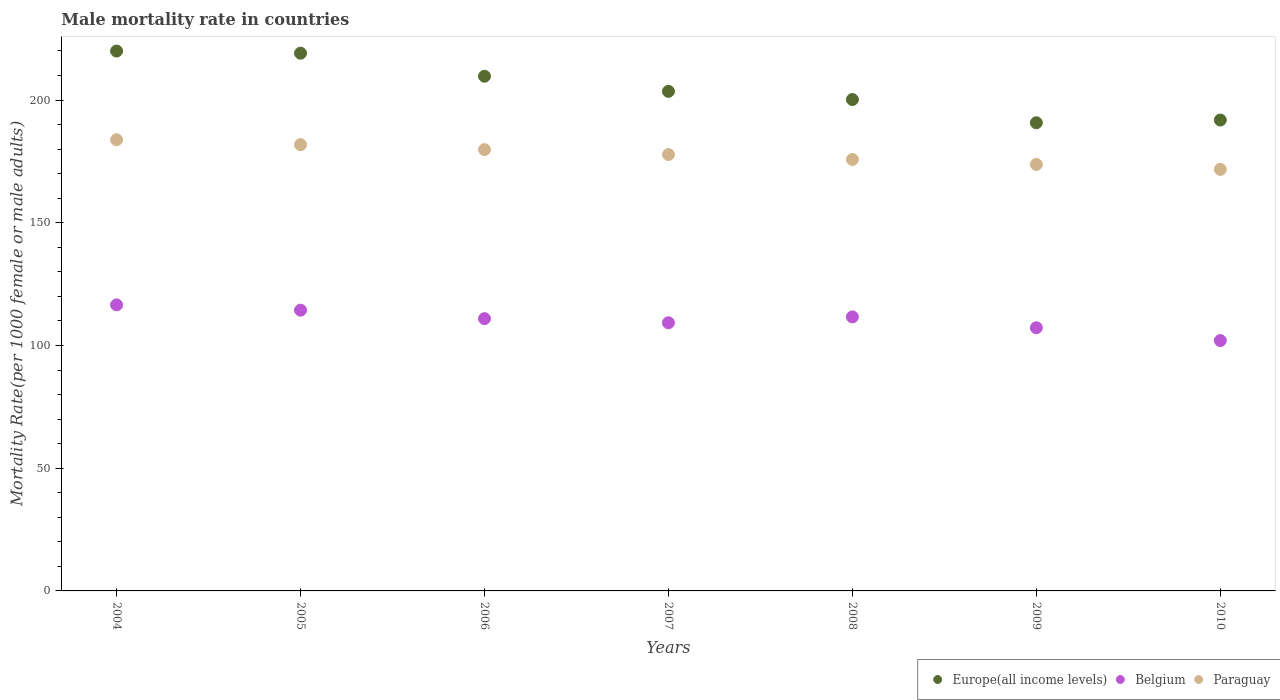Is the number of dotlines equal to the number of legend labels?
Offer a terse response. Yes. What is the male mortality rate in Europe(all income levels) in 2006?
Offer a terse response. 209.7. Across all years, what is the maximum male mortality rate in Paraguay?
Your answer should be very brief. 183.84. Across all years, what is the minimum male mortality rate in Europe(all income levels)?
Offer a very short reply. 190.75. In which year was the male mortality rate in Paraguay maximum?
Keep it short and to the point. 2004. In which year was the male mortality rate in Europe(all income levels) minimum?
Give a very brief answer. 2009. What is the total male mortality rate in Belgium in the graph?
Your response must be concise. 772.02. What is the difference between the male mortality rate in Paraguay in 2007 and that in 2010?
Keep it short and to the point. 6.04. What is the difference between the male mortality rate in Europe(all income levels) in 2006 and the male mortality rate in Paraguay in 2010?
Your answer should be very brief. 37.94. What is the average male mortality rate in Europe(all income levels) per year?
Provide a short and direct response. 205.02. In the year 2004, what is the difference between the male mortality rate in Europe(all income levels) and male mortality rate in Belgium?
Ensure brevity in your answer.  103.41. What is the ratio of the male mortality rate in Paraguay in 2007 to that in 2008?
Make the answer very short. 1.01. Is the difference between the male mortality rate in Europe(all income levels) in 2004 and 2009 greater than the difference between the male mortality rate in Belgium in 2004 and 2009?
Provide a short and direct response. Yes. What is the difference between the highest and the second highest male mortality rate in Europe(all income levels)?
Give a very brief answer. 0.87. What is the difference between the highest and the lowest male mortality rate in Europe(all income levels)?
Your answer should be compact. 29.22. In how many years, is the male mortality rate in Paraguay greater than the average male mortality rate in Paraguay taken over all years?
Offer a terse response. 3. Is the sum of the male mortality rate in Paraguay in 2008 and 2009 greater than the maximum male mortality rate in Europe(all income levels) across all years?
Give a very brief answer. Yes. Is it the case that in every year, the sum of the male mortality rate in Belgium and male mortality rate in Paraguay  is greater than the male mortality rate in Europe(all income levels)?
Your response must be concise. Yes. Is the male mortality rate in Belgium strictly greater than the male mortality rate in Paraguay over the years?
Offer a very short reply. No. How many years are there in the graph?
Your response must be concise. 7. Are the values on the major ticks of Y-axis written in scientific E-notation?
Offer a terse response. No. Does the graph contain any zero values?
Offer a very short reply. No. Does the graph contain grids?
Make the answer very short. No. Where does the legend appear in the graph?
Keep it short and to the point. Bottom right. What is the title of the graph?
Keep it short and to the point. Male mortality rate in countries. What is the label or title of the X-axis?
Your response must be concise. Years. What is the label or title of the Y-axis?
Provide a short and direct response. Mortality Rate(per 1000 female or male adults). What is the Mortality Rate(per 1000 female or male adults) in Europe(all income levels) in 2004?
Your answer should be compact. 219.96. What is the Mortality Rate(per 1000 female or male adults) in Belgium in 2004?
Offer a very short reply. 116.55. What is the Mortality Rate(per 1000 female or male adults) of Paraguay in 2004?
Offer a very short reply. 183.84. What is the Mortality Rate(per 1000 female or male adults) of Europe(all income levels) in 2005?
Give a very brief answer. 219.09. What is the Mortality Rate(per 1000 female or male adults) of Belgium in 2005?
Offer a terse response. 114.39. What is the Mortality Rate(per 1000 female or male adults) in Paraguay in 2005?
Keep it short and to the point. 181.82. What is the Mortality Rate(per 1000 female or male adults) in Europe(all income levels) in 2006?
Offer a terse response. 209.7. What is the Mortality Rate(per 1000 female or male adults) of Belgium in 2006?
Provide a succinct answer. 110.94. What is the Mortality Rate(per 1000 female or male adults) in Paraguay in 2006?
Provide a short and direct response. 179.81. What is the Mortality Rate(per 1000 female or male adults) in Europe(all income levels) in 2007?
Your response must be concise. 203.55. What is the Mortality Rate(per 1000 female or male adults) of Belgium in 2007?
Ensure brevity in your answer.  109.26. What is the Mortality Rate(per 1000 female or male adults) in Paraguay in 2007?
Your answer should be very brief. 177.8. What is the Mortality Rate(per 1000 female or male adults) in Europe(all income levels) in 2008?
Provide a short and direct response. 200.21. What is the Mortality Rate(per 1000 female or male adults) of Belgium in 2008?
Give a very brief answer. 111.64. What is the Mortality Rate(per 1000 female or male adults) of Paraguay in 2008?
Give a very brief answer. 175.78. What is the Mortality Rate(per 1000 female or male adults) of Europe(all income levels) in 2009?
Make the answer very short. 190.75. What is the Mortality Rate(per 1000 female or male adults) of Belgium in 2009?
Offer a very short reply. 107.23. What is the Mortality Rate(per 1000 female or male adults) of Paraguay in 2009?
Make the answer very short. 173.77. What is the Mortality Rate(per 1000 female or male adults) in Europe(all income levels) in 2010?
Make the answer very short. 191.86. What is the Mortality Rate(per 1000 female or male adults) of Belgium in 2010?
Offer a very short reply. 102.02. What is the Mortality Rate(per 1000 female or male adults) in Paraguay in 2010?
Offer a terse response. 171.76. Across all years, what is the maximum Mortality Rate(per 1000 female or male adults) of Europe(all income levels)?
Make the answer very short. 219.96. Across all years, what is the maximum Mortality Rate(per 1000 female or male adults) of Belgium?
Your response must be concise. 116.55. Across all years, what is the maximum Mortality Rate(per 1000 female or male adults) in Paraguay?
Your response must be concise. 183.84. Across all years, what is the minimum Mortality Rate(per 1000 female or male adults) in Europe(all income levels)?
Your answer should be very brief. 190.75. Across all years, what is the minimum Mortality Rate(per 1000 female or male adults) in Belgium?
Your answer should be compact. 102.02. Across all years, what is the minimum Mortality Rate(per 1000 female or male adults) of Paraguay?
Offer a very short reply. 171.76. What is the total Mortality Rate(per 1000 female or male adults) in Europe(all income levels) in the graph?
Provide a succinct answer. 1435.13. What is the total Mortality Rate(per 1000 female or male adults) of Belgium in the graph?
Keep it short and to the point. 772.02. What is the total Mortality Rate(per 1000 female or male adults) of Paraguay in the graph?
Keep it short and to the point. 1244.59. What is the difference between the Mortality Rate(per 1000 female or male adults) of Europe(all income levels) in 2004 and that in 2005?
Ensure brevity in your answer.  0.87. What is the difference between the Mortality Rate(per 1000 female or male adults) of Belgium in 2004 and that in 2005?
Offer a terse response. 2.16. What is the difference between the Mortality Rate(per 1000 female or male adults) in Paraguay in 2004 and that in 2005?
Offer a very short reply. 2.01. What is the difference between the Mortality Rate(per 1000 female or male adults) in Europe(all income levels) in 2004 and that in 2006?
Make the answer very short. 10.26. What is the difference between the Mortality Rate(per 1000 female or male adults) in Belgium in 2004 and that in 2006?
Give a very brief answer. 5.62. What is the difference between the Mortality Rate(per 1000 female or male adults) of Paraguay in 2004 and that in 2006?
Offer a very short reply. 4.03. What is the difference between the Mortality Rate(per 1000 female or male adults) of Europe(all income levels) in 2004 and that in 2007?
Keep it short and to the point. 16.41. What is the difference between the Mortality Rate(per 1000 female or male adults) in Belgium in 2004 and that in 2007?
Keep it short and to the point. 7.3. What is the difference between the Mortality Rate(per 1000 female or male adults) of Paraguay in 2004 and that in 2007?
Keep it short and to the point. 6.04. What is the difference between the Mortality Rate(per 1000 female or male adults) in Europe(all income levels) in 2004 and that in 2008?
Offer a very short reply. 19.75. What is the difference between the Mortality Rate(per 1000 female or male adults) of Belgium in 2004 and that in 2008?
Your answer should be compact. 4.91. What is the difference between the Mortality Rate(per 1000 female or male adults) of Paraguay in 2004 and that in 2008?
Offer a terse response. 8.05. What is the difference between the Mortality Rate(per 1000 female or male adults) of Europe(all income levels) in 2004 and that in 2009?
Give a very brief answer. 29.22. What is the difference between the Mortality Rate(per 1000 female or male adults) of Belgium in 2004 and that in 2009?
Keep it short and to the point. 9.33. What is the difference between the Mortality Rate(per 1000 female or male adults) of Paraguay in 2004 and that in 2009?
Offer a terse response. 10.06. What is the difference between the Mortality Rate(per 1000 female or male adults) of Europe(all income levels) in 2004 and that in 2010?
Ensure brevity in your answer.  28.11. What is the difference between the Mortality Rate(per 1000 female or male adults) of Belgium in 2004 and that in 2010?
Make the answer very short. 14.54. What is the difference between the Mortality Rate(per 1000 female or male adults) in Paraguay in 2004 and that in 2010?
Your answer should be compact. 12.08. What is the difference between the Mortality Rate(per 1000 female or male adults) of Europe(all income levels) in 2005 and that in 2006?
Give a very brief answer. 9.39. What is the difference between the Mortality Rate(per 1000 female or male adults) in Belgium in 2005 and that in 2006?
Your answer should be very brief. 3.45. What is the difference between the Mortality Rate(per 1000 female or male adults) in Paraguay in 2005 and that in 2006?
Provide a succinct answer. 2.01. What is the difference between the Mortality Rate(per 1000 female or male adults) in Europe(all income levels) in 2005 and that in 2007?
Your response must be concise. 15.54. What is the difference between the Mortality Rate(per 1000 female or male adults) of Belgium in 2005 and that in 2007?
Ensure brevity in your answer.  5.13. What is the difference between the Mortality Rate(per 1000 female or male adults) in Paraguay in 2005 and that in 2007?
Keep it short and to the point. 4.03. What is the difference between the Mortality Rate(per 1000 female or male adults) of Europe(all income levels) in 2005 and that in 2008?
Your answer should be very brief. 18.88. What is the difference between the Mortality Rate(per 1000 female or male adults) in Belgium in 2005 and that in 2008?
Your response must be concise. 2.75. What is the difference between the Mortality Rate(per 1000 female or male adults) in Paraguay in 2005 and that in 2008?
Offer a very short reply. 6.04. What is the difference between the Mortality Rate(per 1000 female or male adults) of Europe(all income levels) in 2005 and that in 2009?
Your answer should be very brief. 28.35. What is the difference between the Mortality Rate(per 1000 female or male adults) in Belgium in 2005 and that in 2009?
Offer a very short reply. 7.16. What is the difference between the Mortality Rate(per 1000 female or male adults) in Paraguay in 2005 and that in 2009?
Your answer should be compact. 8.05. What is the difference between the Mortality Rate(per 1000 female or male adults) in Europe(all income levels) in 2005 and that in 2010?
Provide a succinct answer. 27.24. What is the difference between the Mortality Rate(per 1000 female or male adults) of Belgium in 2005 and that in 2010?
Your answer should be very brief. 12.37. What is the difference between the Mortality Rate(per 1000 female or male adults) of Paraguay in 2005 and that in 2010?
Provide a short and direct response. 10.06. What is the difference between the Mortality Rate(per 1000 female or male adults) in Europe(all income levels) in 2006 and that in 2007?
Your answer should be compact. 6.15. What is the difference between the Mortality Rate(per 1000 female or male adults) of Belgium in 2006 and that in 2007?
Offer a terse response. 1.68. What is the difference between the Mortality Rate(per 1000 female or male adults) of Paraguay in 2006 and that in 2007?
Your answer should be compact. 2.01. What is the difference between the Mortality Rate(per 1000 female or male adults) in Europe(all income levels) in 2006 and that in 2008?
Give a very brief answer. 9.49. What is the difference between the Mortality Rate(per 1000 female or male adults) in Belgium in 2006 and that in 2008?
Your response must be concise. -0.71. What is the difference between the Mortality Rate(per 1000 female or male adults) in Paraguay in 2006 and that in 2008?
Keep it short and to the point. 4.03. What is the difference between the Mortality Rate(per 1000 female or male adults) in Europe(all income levels) in 2006 and that in 2009?
Provide a short and direct response. 18.96. What is the difference between the Mortality Rate(per 1000 female or male adults) of Belgium in 2006 and that in 2009?
Provide a succinct answer. 3.71. What is the difference between the Mortality Rate(per 1000 female or male adults) in Paraguay in 2006 and that in 2009?
Your answer should be compact. 6.04. What is the difference between the Mortality Rate(per 1000 female or male adults) in Europe(all income levels) in 2006 and that in 2010?
Offer a terse response. 17.85. What is the difference between the Mortality Rate(per 1000 female or male adults) in Belgium in 2006 and that in 2010?
Your answer should be very brief. 8.92. What is the difference between the Mortality Rate(per 1000 female or male adults) of Paraguay in 2006 and that in 2010?
Provide a succinct answer. 8.05. What is the difference between the Mortality Rate(per 1000 female or male adults) in Europe(all income levels) in 2007 and that in 2008?
Your answer should be compact. 3.34. What is the difference between the Mortality Rate(per 1000 female or male adults) of Belgium in 2007 and that in 2008?
Offer a terse response. -2.39. What is the difference between the Mortality Rate(per 1000 female or male adults) of Paraguay in 2007 and that in 2008?
Provide a succinct answer. 2.01. What is the difference between the Mortality Rate(per 1000 female or male adults) of Europe(all income levels) in 2007 and that in 2009?
Make the answer very short. 12.8. What is the difference between the Mortality Rate(per 1000 female or male adults) of Belgium in 2007 and that in 2009?
Offer a terse response. 2.03. What is the difference between the Mortality Rate(per 1000 female or male adults) in Paraguay in 2007 and that in 2009?
Your answer should be compact. 4.02. What is the difference between the Mortality Rate(per 1000 female or male adults) in Europe(all income levels) in 2007 and that in 2010?
Make the answer very short. 11.7. What is the difference between the Mortality Rate(per 1000 female or male adults) of Belgium in 2007 and that in 2010?
Keep it short and to the point. 7.24. What is the difference between the Mortality Rate(per 1000 female or male adults) of Paraguay in 2007 and that in 2010?
Offer a terse response. 6.04. What is the difference between the Mortality Rate(per 1000 female or male adults) in Europe(all income levels) in 2008 and that in 2009?
Make the answer very short. 9.46. What is the difference between the Mortality Rate(per 1000 female or male adults) in Belgium in 2008 and that in 2009?
Ensure brevity in your answer.  4.42. What is the difference between the Mortality Rate(per 1000 female or male adults) in Paraguay in 2008 and that in 2009?
Offer a terse response. 2.01. What is the difference between the Mortality Rate(per 1000 female or male adults) in Europe(all income levels) in 2008 and that in 2010?
Provide a succinct answer. 8.35. What is the difference between the Mortality Rate(per 1000 female or male adults) of Belgium in 2008 and that in 2010?
Keep it short and to the point. 9.62. What is the difference between the Mortality Rate(per 1000 female or male adults) of Paraguay in 2008 and that in 2010?
Ensure brevity in your answer.  4.02. What is the difference between the Mortality Rate(per 1000 female or male adults) of Europe(all income levels) in 2009 and that in 2010?
Keep it short and to the point. -1.11. What is the difference between the Mortality Rate(per 1000 female or male adults) in Belgium in 2009 and that in 2010?
Your answer should be compact. 5.21. What is the difference between the Mortality Rate(per 1000 female or male adults) of Paraguay in 2009 and that in 2010?
Keep it short and to the point. 2.01. What is the difference between the Mortality Rate(per 1000 female or male adults) in Europe(all income levels) in 2004 and the Mortality Rate(per 1000 female or male adults) in Belgium in 2005?
Give a very brief answer. 105.58. What is the difference between the Mortality Rate(per 1000 female or male adults) in Europe(all income levels) in 2004 and the Mortality Rate(per 1000 female or male adults) in Paraguay in 2005?
Provide a succinct answer. 38.14. What is the difference between the Mortality Rate(per 1000 female or male adults) of Belgium in 2004 and the Mortality Rate(per 1000 female or male adults) of Paraguay in 2005?
Provide a short and direct response. -65.27. What is the difference between the Mortality Rate(per 1000 female or male adults) in Europe(all income levels) in 2004 and the Mortality Rate(per 1000 female or male adults) in Belgium in 2006?
Ensure brevity in your answer.  109.03. What is the difference between the Mortality Rate(per 1000 female or male adults) in Europe(all income levels) in 2004 and the Mortality Rate(per 1000 female or male adults) in Paraguay in 2006?
Keep it short and to the point. 40.15. What is the difference between the Mortality Rate(per 1000 female or male adults) in Belgium in 2004 and the Mortality Rate(per 1000 female or male adults) in Paraguay in 2006?
Make the answer very short. -63.26. What is the difference between the Mortality Rate(per 1000 female or male adults) of Europe(all income levels) in 2004 and the Mortality Rate(per 1000 female or male adults) of Belgium in 2007?
Give a very brief answer. 110.71. What is the difference between the Mortality Rate(per 1000 female or male adults) in Europe(all income levels) in 2004 and the Mortality Rate(per 1000 female or male adults) in Paraguay in 2007?
Your answer should be very brief. 42.17. What is the difference between the Mortality Rate(per 1000 female or male adults) of Belgium in 2004 and the Mortality Rate(per 1000 female or male adults) of Paraguay in 2007?
Ensure brevity in your answer.  -61.24. What is the difference between the Mortality Rate(per 1000 female or male adults) in Europe(all income levels) in 2004 and the Mortality Rate(per 1000 female or male adults) in Belgium in 2008?
Your answer should be compact. 108.32. What is the difference between the Mortality Rate(per 1000 female or male adults) of Europe(all income levels) in 2004 and the Mortality Rate(per 1000 female or male adults) of Paraguay in 2008?
Make the answer very short. 44.18. What is the difference between the Mortality Rate(per 1000 female or male adults) of Belgium in 2004 and the Mortality Rate(per 1000 female or male adults) of Paraguay in 2008?
Offer a terse response. -59.23. What is the difference between the Mortality Rate(per 1000 female or male adults) of Europe(all income levels) in 2004 and the Mortality Rate(per 1000 female or male adults) of Belgium in 2009?
Give a very brief answer. 112.74. What is the difference between the Mortality Rate(per 1000 female or male adults) in Europe(all income levels) in 2004 and the Mortality Rate(per 1000 female or male adults) in Paraguay in 2009?
Ensure brevity in your answer.  46.19. What is the difference between the Mortality Rate(per 1000 female or male adults) in Belgium in 2004 and the Mortality Rate(per 1000 female or male adults) in Paraguay in 2009?
Ensure brevity in your answer.  -57.22. What is the difference between the Mortality Rate(per 1000 female or male adults) in Europe(all income levels) in 2004 and the Mortality Rate(per 1000 female or male adults) in Belgium in 2010?
Keep it short and to the point. 117.95. What is the difference between the Mortality Rate(per 1000 female or male adults) of Europe(all income levels) in 2004 and the Mortality Rate(per 1000 female or male adults) of Paraguay in 2010?
Offer a terse response. 48.2. What is the difference between the Mortality Rate(per 1000 female or male adults) in Belgium in 2004 and the Mortality Rate(per 1000 female or male adults) in Paraguay in 2010?
Provide a succinct answer. -55.21. What is the difference between the Mortality Rate(per 1000 female or male adults) in Europe(all income levels) in 2005 and the Mortality Rate(per 1000 female or male adults) in Belgium in 2006?
Give a very brief answer. 108.16. What is the difference between the Mortality Rate(per 1000 female or male adults) in Europe(all income levels) in 2005 and the Mortality Rate(per 1000 female or male adults) in Paraguay in 2006?
Give a very brief answer. 39.28. What is the difference between the Mortality Rate(per 1000 female or male adults) in Belgium in 2005 and the Mortality Rate(per 1000 female or male adults) in Paraguay in 2006?
Your response must be concise. -65.42. What is the difference between the Mortality Rate(per 1000 female or male adults) in Europe(all income levels) in 2005 and the Mortality Rate(per 1000 female or male adults) in Belgium in 2007?
Your response must be concise. 109.84. What is the difference between the Mortality Rate(per 1000 female or male adults) in Europe(all income levels) in 2005 and the Mortality Rate(per 1000 female or male adults) in Paraguay in 2007?
Your answer should be compact. 41.3. What is the difference between the Mortality Rate(per 1000 female or male adults) in Belgium in 2005 and the Mortality Rate(per 1000 female or male adults) in Paraguay in 2007?
Ensure brevity in your answer.  -63.41. What is the difference between the Mortality Rate(per 1000 female or male adults) of Europe(all income levels) in 2005 and the Mortality Rate(per 1000 female or male adults) of Belgium in 2008?
Provide a succinct answer. 107.45. What is the difference between the Mortality Rate(per 1000 female or male adults) of Europe(all income levels) in 2005 and the Mortality Rate(per 1000 female or male adults) of Paraguay in 2008?
Provide a short and direct response. 43.31. What is the difference between the Mortality Rate(per 1000 female or male adults) of Belgium in 2005 and the Mortality Rate(per 1000 female or male adults) of Paraguay in 2008?
Offer a terse response. -61.4. What is the difference between the Mortality Rate(per 1000 female or male adults) in Europe(all income levels) in 2005 and the Mortality Rate(per 1000 female or male adults) in Belgium in 2009?
Offer a very short reply. 111.87. What is the difference between the Mortality Rate(per 1000 female or male adults) in Europe(all income levels) in 2005 and the Mortality Rate(per 1000 female or male adults) in Paraguay in 2009?
Offer a terse response. 45.32. What is the difference between the Mortality Rate(per 1000 female or male adults) in Belgium in 2005 and the Mortality Rate(per 1000 female or male adults) in Paraguay in 2009?
Ensure brevity in your answer.  -59.38. What is the difference between the Mortality Rate(per 1000 female or male adults) in Europe(all income levels) in 2005 and the Mortality Rate(per 1000 female or male adults) in Belgium in 2010?
Your answer should be compact. 117.08. What is the difference between the Mortality Rate(per 1000 female or male adults) of Europe(all income levels) in 2005 and the Mortality Rate(per 1000 female or male adults) of Paraguay in 2010?
Provide a succinct answer. 47.33. What is the difference between the Mortality Rate(per 1000 female or male adults) of Belgium in 2005 and the Mortality Rate(per 1000 female or male adults) of Paraguay in 2010?
Your answer should be very brief. -57.37. What is the difference between the Mortality Rate(per 1000 female or male adults) in Europe(all income levels) in 2006 and the Mortality Rate(per 1000 female or male adults) in Belgium in 2007?
Provide a succinct answer. 100.45. What is the difference between the Mortality Rate(per 1000 female or male adults) in Europe(all income levels) in 2006 and the Mortality Rate(per 1000 female or male adults) in Paraguay in 2007?
Your answer should be very brief. 31.91. What is the difference between the Mortality Rate(per 1000 female or male adults) in Belgium in 2006 and the Mortality Rate(per 1000 female or male adults) in Paraguay in 2007?
Offer a terse response. -66.86. What is the difference between the Mortality Rate(per 1000 female or male adults) in Europe(all income levels) in 2006 and the Mortality Rate(per 1000 female or male adults) in Belgium in 2008?
Your response must be concise. 98.06. What is the difference between the Mortality Rate(per 1000 female or male adults) in Europe(all income levels) in 2006 and the Mortality Rate(per 1000 female or male adults) in Paraguay in 2008?
Ensure brevity in your answer.  33.92. What is the difference between the Mortality Rate(per 1000 female or male adults) in Belgium in 2006 and the Mortality Rate(per 1000 female or male adults) in Paraguay in 2008?
Provide a short and direct response. -64.85. What is the difference between the Mortality Rate(per 1000 female or male adults) in Europe(all income levels) in 2006 and the Mortality Rate(per 1000 female or male adults) in Belgium in 2009?
Your answer should be compact. 102.48. What is the difference between the Mortality Rate(per 1000 female or male adults) of Europe(all income levels) in 2006 and the Mortality Rate(per 1000 female or male adults) of Paraguay in 2009?
Offer a terse response. 35.93. What is the difference between the Mortality Rate(per 1000 female or male adults) in Belgium in 2006 and the Mortality Rate(per 1000 female or male adults) in Paraguay in 2009?
Keep it short and to the point. -62.84. What is the difference between the Mortality Rate(per 1000 female or male adults) of Europe(all income levels) in 2006 and the Mortality Rate(per 1000 female or male adults) of Belgium in 2010?
Your response must be concise. 107.69. What is the difference between the Mortality Rate(per 1000 female or male adults) of Europe(all income levels) in 2006 and the Mortality Rate(per 1000 female or male adults) of Paraguay in 2010?
Provide a succinct answer. 37.94. What is the difference between the Mortality Rate(per 1000 female or male adults) of Belgium in 2006 and the Mortality Rate(per 1000 female or male adults) of Paraguay in 2010?
Offer a terse response. -60.83. What is the difference between the Mortality Rate(per 1000 female or male adults) in Europe(all income levels) in 2007 and the Mortality Rate(per 1000 female or male adults) in Belgium in 2008?
Make the answer very short. 91.91. What is the difference between the Mortality Rate(per 1000 female or male adults) in Europe(all income levels) in 2007 and the Mortality Rate(per 1000 female or male adults) in Paraguay in 2008?
Ensure brevity in your answer.  27.77. What is the difference between the Mortality Rate(per 1000 female or male adults) of Belgium in 2007 and the Mortality Rate(per 1000 female or male adults) of Paraguay in 2008?
Make the answer very short. -66.53. What is the difference between the Mortality Rate(per 1000 female or male adults) of Europe(all income levels) in 2007 and the Mortality Rate(per 1000 female or male adults) of Belgium in 2009?
Keep it short and to the point. 96.33. What is the difference between the Mortality Rate(per 1000 female or male adults) in Europe(all income levels) in 2007 and the Mortality Rate(per 1000 female or male adults) in Paraguay in 2009?
Offer a terse response. 29.78. What is the difference between the Mortality Rate(per 1000 female or male adults) in Belgium in 2007 and the Mortality Rate(per 1000 female or male adults) in Paraguay in 2009?
Provide a succinct answer. -64.52. What is the difference between the Mortality Rate(per 1000 female or male adults) of Europe(all income levels) in 2007 and the Mortality Rate(per 1000 female or male adults) of Belgium in 2010?
Give a very brief answer. 101.53. What is the difference between the Mortality Rate(per 1000 female or male adults) of Europe(all income levels) in 2007 and the Mortality Rate(per 1000 female or male adults) of Paraguay in 2010?
Offer a very short reply. 31.79. What is the difference between the Mortality Rate(per 1000 female or male adults) of Belgium in 2007 and the Mortality Rate(per 1000 female or male adults) of Paraguay in 2010?
Make the answer very short. -62.51. What is the difference between the Mortality Rate(per 1000 female or male adults) in Europe(all income levels) in 2008 and the Mortality Rate(per 1000 female or male adults) in Belgium in 2009?
Offer a very short reply. 92.98. What is the difference between the Mortality Rate(per 1000 female or male adults) of Europe(all income levels) in 2008 and the Mortality Rate(per 1000 female or male adults) of Paraguay in 2009?
Ensure brevity in your answer.  26.44. What is the difference between the Mortality Rate(per 1000 female or male adults) of Belgium in 2008 and the Mortality Rate(per 1000 female or male adults) of Paraguay in 2009?
Your answer should be compact. -62.13. What is the difference between the Mortality Rate(per 1000 female or male adults) of Europe(all income levels) in 2008 and the Mortality Rate(per 1000 female or male adults) of Belgium in 2010?
Ensure brevity in your answer.  98.19. What is the difference between the Mortality Rate(per 1000 female or male adults) of Europe(all income levels) in 2008 and the Mortality Rate(per 1000 female or male adults) of Paraguay in 2010?
Ensure brevity in your answer.  28.45. What is the difference between the Mortality Rate(per 1000 female or male adults) of Belgium in 2008 and the Mortality Rate(per 1000 female or male adults) of Paraguay in 2010?
Make the answer very short. -60.12. What is the difference between the Mortality Rate(per 1000 female or male adults) in Europe(all income levels) in 2009 and the Mortality Rate(per 1000 female or male adults) in Belgium in 2010?
Give a very brief answer. 88.73. What is the difference between the Mortality Rate(per 1000 female or male adults) in Europe(all income levels) in 2009 and the Mortality Rate(per 1000 female or male adults) in Paraguay in 2010?
Provide a succinct answer. 18.99. What is the difference between the Mortality Rate(per 1000 female or male adults) of Belgium in 2009 and the Mortality Rate(per 1000 female or male adults) of Paraguay in 2010?
Your answer should be very brief. -64.53. What is the average Mortality Rate(per 1000 female or male adults) in Europe(all income levels) per year?
Your answer should be very brief. 205.02. What is the average Mortality Rate(per 1000 female or male adults) in Belgium per year?
Your answer should be compact. 110.29. What is the average Mortality Rate(per 1000 female or male adults) in Paraguay per year?
Provide a short and direct response. 177.8. In the year 2004, what is the difference between the Mortality Rate(per 1000 female or male adults) in Europe(all income levels) and Mortality Rate(per 1000 female or male adults) in Belgium?
Give a very brief answer. 103.41. In the year 2004, what is the difference between the Mortality Rate(per 1000 female or male adults) of Europe(all income levels) and Mortality Rate(per 1000 female or male adults) of Paraguay?
Your answer should be very brief. 36.13. In the year 2004, what is the difference between the Mortality Rate(per 1000 female or male adults) in Belgium and Mortality Rate(per 1000 female or male adults) in Paraguay?
Give a very brief answer. -67.28. In the year 2005, what is the difference between the Mortality Rate(per 1000 female or male adults) of Europe(all income levels) and Mortality Rate(per 1000 female or male adults) of Belgium?
Provide a short and direct response. 104.7. In the year 2005, what is the difference between the Mortality Rate(per 1000 female or male adults) in Europe(all income levels) and Mortality Rate(per 1000 female or male adults) in Paraguay?
Ensure brevity in your answer.  37.27. In the year 2005, what is the difference between the Mortality Rate(per 1000 female or male adults) in Belgium and Mortality Rate(per 1000 female or male adults) in Paraguay?
Your answer should be very brief. -67.44. In the year 2006, what is the difference between the Mortality Rate(per 1000 female or male adults) in Europe(all income levels) and Mortality Rate(per 1000 female or male adults) in Belgium?
Your answer should be compact. 98.77. In the year 2006, what is the difference between the Mortality Rate(per 1000 female or male adults) in Europe(all income levels) and Mortality Rate(per 1000 female or male adults) in Paraguay?
Keep it short and to the point. 29.89. In the year 2006, what is the difference between the Mortality Rate(per 1000 female or male adults) of Belgium and Mortality Rate(per 1000 female or male adults) of Paraguay?
Offer a terse response. -68.87. In the year 2007, what is the difference between the Mortality Rate(per 1000 female or male adults) of Europe(all income levels) and Mortality Rate(per 1000 female or male adults) of Belgium?
Your response must be concise. 94.3. In the year 2007, what is the difference between the Mortality Rate(per 1000 female or male adults) of Europe(all income levels) and Mortality Rate(per 1000 female or male adults) of Paraguay?
Your answer should be very brief. 25.75. In the year 2007, what is the difference between the Mortality Rate(per 1000 female or male adults) in Belgium and Mortality Rate(per 1000 female or male adults) in Paraguay?
Give a very brief answer. -68.54. In the year 2008, what is the difference between the Mortality Rate(per 1000 female or male adults) in Europe(all income levels) and Mortality Rate(per 1000 female or male adults) in Belgium?
Your answer should be very brief. 88.57. In the year 2008, what is the difference between the Mortality Rate(per 1000 female or male adults) of Europe(all income levels) and Mortality Rate(per 1000 female or male adults) of Paraguay?
Your answer should be compact. 24.42. In the year 2008, what is the difference between the Mortality Rate(per 1000 female or male adults) of Belgium and Mortality Rate(per 1000 female or male adults) of Paraguay?
Make the answer very short. -64.14. In the year 2009, what is the difference between the Mortality Rate(per 1000 female or male adults) of Europe(all income levels) and Mortality Rate(per 1000 female or male adults) of Belgium?
Give a very brief answer. 83.52. In the year 2009, what is the difference between the Mortality Rate(per 1000 female or male adults) of Europe(all income levels) and Mortality Rate(per 1000 female or male adults) of Paraguay?
Your answer should be very brief. 16.97. In the year 2009, what is the difference between the Mortality Rate(per 1000 female or male adults) in Belgium and Mortality Rate(per 1000 female or male adults) in Paraguay?
Keep it short and to the point. -66.55. In the year 2010, what is the difference between the Mortality Rate(per 1000 female or male adults) in Europe(all income levels) and Mortality Rate(per 1000 female or male adults) in Belgium?
Make the answer very short. 89.84. In the year 2010, what is the difference between the Mortality Rate(per 1000 female or male adults) of Europe(all income levels) and Mortality Rate(per 1000 female or male adults) of Paraguay?
Your answer should be very brief. 20.09. In the year 2010, what is the difference between the Mortality Rate(per 1000 female or male adults) in Belgium and Mortality Rate(per 1000 female or male adults) in Paraguay?
Your answer should be compact. -69.74. What is the ratio of the Mortality Rate(per 1000 female or male adults) of Europe(all income levels) in 2004 to that in 2005?
Your response must be concise. 1. What is the ratio of the Mortality Rate(per 1000 female or male adults) of Belgium in 2004 to that in 2005?
Your answer should be compact. 1.02. What is the ratio of the Mortality Rate(per 1000 female or male adults) in Paraguay in 2004 to that in 2005?
Give a very brief answer. 1.01. What is the ratio of the Mortality Rate(per 1000 female or male adults) of Europe(all income levels) in 2004 to that in 2006?
Give a very brief answer. 1.05. What is the ratio of the Mortality Rate(per 1000 female or male adults) in Belgium in 2004 to that in 2006?
Ensure brevity in your answer.  1.05. What is the ratio of the Mortality Rate(per 1000 female or male adults) of Paraguay in 2004 to that in 2006?
Your answer should be very brief. 1.02. What is the ratio of the Mortality Rate(per 1000 female or male adults) of Europe(all income levels) in 2004 to that in 2007?
Keep it short and to the point. 1.08. What is the ratio of the Mortality Rate(per 1000 female or male adults) of Belgium in 2004 to that in 2007?
Offer a terse response. 1.07. What is the ratio of the Mortality Rate(per 1000 female or male adults) of Paraguay in 2004 to that in 2007?
Your answer should be compact. 1.03. What is the ratio of the Mortality Rate(per 1000 female or male adults) of Europe(all income levels) in 2004 to that in 2008?
Give a very brief answer. 1.1. What is the ratio of the Mortality Rate(per 1000 female or male adults) in Belgium in 2004 to that in 2008?
Keep it short and to the point. 1.04. What is the ratio of the Mortality Rate(per 1000 female or male adults) in Paraguay in 2004 to that in 2008?
Ensure brevity in your answer.  1.05. What is the ratio of the Mortality Rate(per 1000 female or male adults) in Europe(all income levels) in 2004 to that in 2009?
Make the answer very short. 1.15. What is the ratio of the Mortality Rate(per 1000 female or male adults) in Belgium in 2004 to that in 2009?
Your answer should be very brief. 1.09. What is the ratio of the Mortality Rate(per 1000 female or male adults) of Paraguay in 2004 to that in 2009?
Make the answer very short. 1.06. What is the ratio of the Mortality Rate(per 1000 female or male adults) of Europe(all income levels) in 2004 to that in 2010?
Give a very brief answer. 1.15. What is the ratio of the Mortality Rate(per 1000 female or male adults) in Belgium in 2004 to that in 2010?
Your answer should be compact. 1.14. What is the ratio of the Mortality Rate(per 1000 female or male adults) in Paraguay in 2004 to that in 2010?
Offer a terse response. 1.07. What is the ratio of the Mortality Rate(per 1000 female or male adults) in Europe(all income levels) in 2005 to that in 2006?
Keep it short and to the point. 1.04. What is the ratio of the Mortality Rate(per 1000 female or male adults) of Belgium in 2005 to that in 2006?
Your answer should be very brief. 1.03. What is the ratio of the Mortality Rate(per 1000 female or male adults) in Paraguay in 2005 to that in 2006?
Offer a very short reply. 1.01. What is the ratio of the Mortality Rate(per 1000 female or male adults) in Europe(all income levels) in 2005 to that in 2007?
Provide a succinct answer. 1.08. What is the ratio of the Mortality Rate(per 1000 female or male adults) in Belgium in 2005 to that in 2007?
Ensure brevity in your answer.  1.05. What is the ratio of the Mortality Rate(per 1000 female or male adults) of Paraguay in 2005 to that in 2007?
Your answer should be compact. 1.02. What is the ratio of the Mortality Rate(per 1000 female or male adults) in Europe(all income levels) in 2005 to that in 2008?
Offer a terse response. 1.09. What is the ratio of the Mortality Rate(per 1000 female or male adults) of Belgium in 2005 to that in 2008?
Your answer should be compact. 1.02. What is the ratio of the Mortality Rate(per 1000 female or male adults) in Paraguay in 2005 to that in 2008?
Offer a terse response. 1.03. What is the ratio of the Mortality Rate(per 1000 female or male adults) in Europe(all income levels) in 2005 to that in 2009?
Your answer should be compact. 1.15. What is the ratio of the Mortality Rate(per 1000 female or male adults) in Belgium in 2005 to that in 2009?
Offer a very short reply. 1.07. What is the ratio of the Mortality Rate(per 1000 female or male adults) of Paraguay in 2005 to that in 2009?
Offer a terse response. 1.05. What is the ratio of the Mortality Rate(per 1000 female or male adults) in Europe(all income levels) in 2005 to that in 2010?
Provide a succinct answer. 1.14. What is the ratio of the Mortality Rate(per 1000 female or male adults) in Belgium in 2005 to that in 2010?
Provide a succinct answer. 1.12. What is the ratio of the Mortality Rate(per 1000 female or male adults) of Paraguay in 2005 to that in 2010?
Ensure brevity in your answer.  1.06. What is the ratio of the Mortality Rate(per 1000 female or male adults) in Europe(all income levels) in 2006 to that in 2007?
Make the answer very short. 1.03. What is the ratio of the Mortality Rate(per 1000 female or male adults) in Belgium in 2006 to that in 2007?
Provide a succinct answer. 1.02. What is the ratio of the Mortality Rate(per 1000 female or male adults) in Paraguay in 2006 to that in 2007?
Make the answer very short. 1.01. What is the ratio of the Mortality Rate(per 1000 female or male adults) of Europe(all income levels) in 2006 to that in 2008?
Offer a terse response. 1.05. What is the ratio of the Mortality Rate(per 1000 female or male adults) in Belgium in 2006 to that in 2008?
Make the answer very short. 0.99. What is the ratio of the Mortality Rate(per 1000 female or male adults) of Paraguay in 2006 to that in 2008?
Give a very brief answer. 1.02. What is the ratio of the Mortality Rate(per 1000 female or male adults) in Europe(all income levels) in 2006 to that in 2009?
Provide a short and direct response. 1.1. What is the ratio of the Mortality Rate(per 1000 female or male adults) of Belgium in 2006 to that in 2009?
Offer a terse response. 1.03. What is the ratio of the Mortality Rate(per 1000 female or male adults) in Paraguay in 2006 to that in 2009?
Your response must be concise. 1.03. What is the ratio of the Mortality Rate(per 1000 female or male adults) of Europe(all income levels) in 2006 to that in 2010?
Your answer should be very brief. 1.09. What is the ratio of the Mortality Rate(per 1000 female or male adults) of Belgium in 2006 to that in 2010?
Your answer should be compact. 1.09. What is the ratio of the Mortality Rate(per 1000 female or male adults) of Paraguay in 2006 to that in 2010?
Provide a succinct answer. 1.05. What is the ratio of the Mortality Rate(per 1000 female or male adults) of Europe(all income levels) in 2007 to that in 2008?
Ensure brevity in your answer.  1.02. What is the ratio of the Mortality Rate(per 1000 female or male adults) in Belgium in 2007 to that in 2008?
Provide a succinct answer. 0.98. What is the ratio of the Mortality Rate(per 1000 female or male adults) of Paraguay in 2007 to that in 2008?
Make the answer very short. 1.01. What is the ratio of the Mortality Rate(per 1000 female or male adults) in Europe(all income levels) in 2007 to that in 2009?
Your answer should be compact. 1.07. What is the ratio of the Mortality Rate(per 1000 female or male adults) of Belgium in 2007 to that in 2009?
Offer a very short reply. 1.02. What is the ratio of the Mortality Rate(per 1000 female or male adults) of Paraguay in 2007 to that in 2009?
Offer a very short reply. 1.02. What is the ratio of the Mortality Rate(per 1000 female or male adults) of Europe(all income levels) in 2007 to that in 2010?
Your response must be concise. 1.06. What is the ratio of the Mortality Rate(per 1000 female or male adults) in Belgium in 2007 to that in 2010?
Ensure brevity in your answer.  1.07. What is the ratio of the Mortality Rate(per 1000 female or male adults) in Paraguay in 2007 to that in 2010?
Your response must be concise. 1.04. What is the ratio of the Mortality Rate(per 1000 female or male adults) of Europe(all income levels) in 2008 to that in 2009?
Offer a terse response. 1.05. What is the ratio of the Mortality Rate(per 1000 female or male adults) of Belgium in 2008 to that in 2009?
Keep it short and to the point. 1.04. What is the ratio of the Mortality Rate(per 1000 female or male adults) of Paraguay in 2008 to that in 2009?
Ensure brevity in your answer.  1.01. What is the ratio of the Mortality Rate(per 1000 female or male adults) in Europe(all income levels) in 2008 to that in 2010?
Make the answer very short. 1.04. What is the ratio of the Mortality Rate(per 1000 female or male adults) of Belgium in 2008 to that in 2010?
Offer a very short reply. 1.09. What is the ratio of the Mortality Rate(per 1000 female or male adults) of Paraguay in 2008 to that in 2010?
Offer a very short reply. 1.02. What is the ratio of the Mortality Rate(per 1000 female or male adults) of Belgium in 2009 to that in 2010?
Your answer should be very brief. 1.05. What is the ratio of the Mortality Rate(per 1000 female or male adults) in Paraguay in 2009 to that in 2010?
Your response must be concise. 1.01. What is the difference between the highest and the second highest Mortality Rate(per 1000 female or male adults) in Europe(all income levels)?
Provide a short and direct response. 0.87. What is the difference between the highest and the second highest Mortality Rate(per 1000 female or male adults) of Belgium?
Provide a succinct answer. 2.16. What is the difference between the highest and the second highest Mortality Rate(per 1000 female or male adults) of Paraguay?
Keep it short and to the point. 2.01. What is the difference between the highest and the lowest Mortality Rate(per 1000 female or male adults) of Europe(all income levels)?
Your answer should be very brief. 29.22. What is the difference between the highest and the lowest Mortality Rate(per 1000 female or male adults) in Belgium?
Make the answer very short. 14.54. What is the difference between the highest and the lowest Mortality Rate(per 1000 female or male adults) in Paraguay?
Provide a short and direct response. 12.08. 